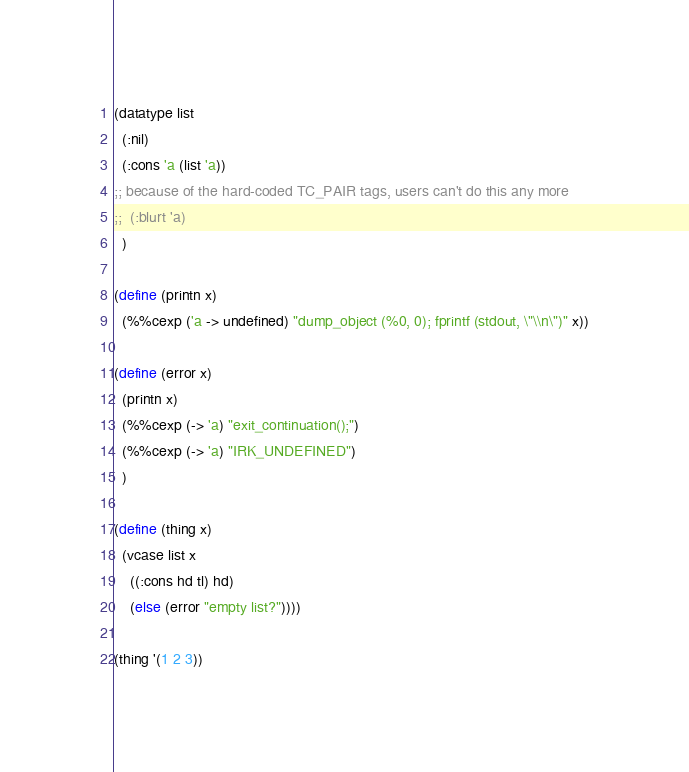<code> <loc_0><loc_0><loc_500><loc_500><_Scheme_>
(datatype list
  (:nil)
  (:cons 'a (list 'a))
;; because of the hard-coded TC_PAIR tags, users can't do this any more
;;  (:blurt 'a)
  )

(define (printn x)
  (%%cexp ('a -> undefined) "dump_object (%0, 0); fprintf (stdout, \"\\n\")" x))

(define (error x)
  (printn x)
  (%%cexp (-> 'a) "exit_continuation();")
  (%%cexp (-> 'a) "IRK_UNDEFINED")
  )

(define (thing x)
  (vcase list x
    ((:cons hd tl) hd)
    (else (error "empty list?"))))

(thing '(1 2 3))
</code> 